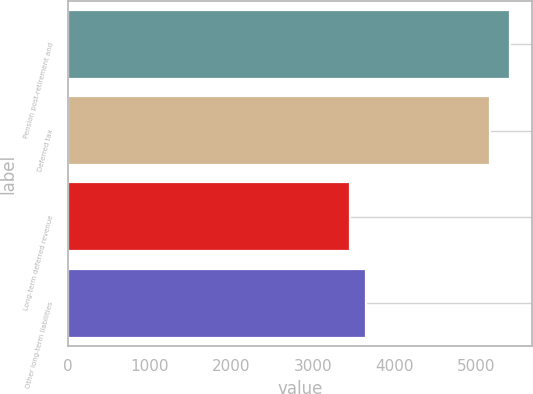Convert chart to OTSL. <chart><loc_0><loc_0><loc_500><loc_500><bar_chart><fcel>Pension post-retirement and<fcel>Deferred tax<fcel>Long-term deferred revenue<fcel>Other long-term liabilities<nl><fcel>5414<fcel>5163<fcel>3453<fcel>3649.1<nl></chart> 